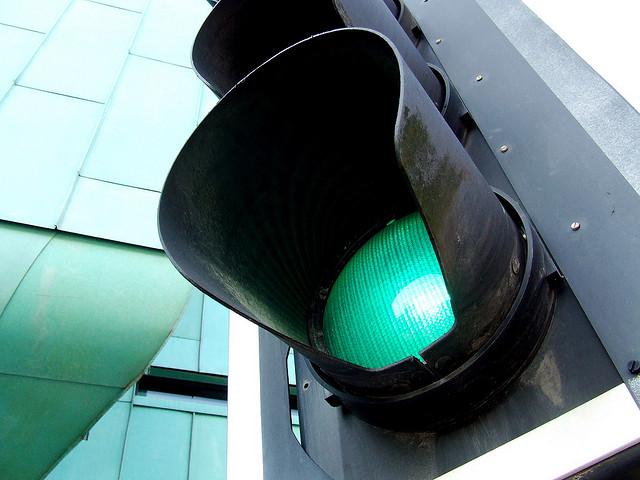What color is the traffic light?
Short answer required. Green. Is the bottom light lit up?
Give a very brief answer. Yes. Is the traffic signal red?
Write a very short answer. No. 